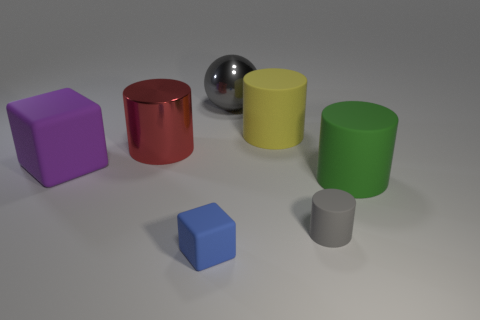Subtract all green cubes. Subtract all brown cylinders. How many cubes are left? 2 Add 3 gray matte cylinders. How many objects exist? 10 Subtract all cylinders. How many objects are left? 3 Subtract 1 purple cubes. How many objects are left? 6 Subtract all big gray matte spheres. Subtract all big purple cubes. How many objects are left? 6 Add 3 big green cylinders. How many big green cylinders are left? 4 Add 7 blue matte cylinders. How many blue matte cylinders exist? 7 